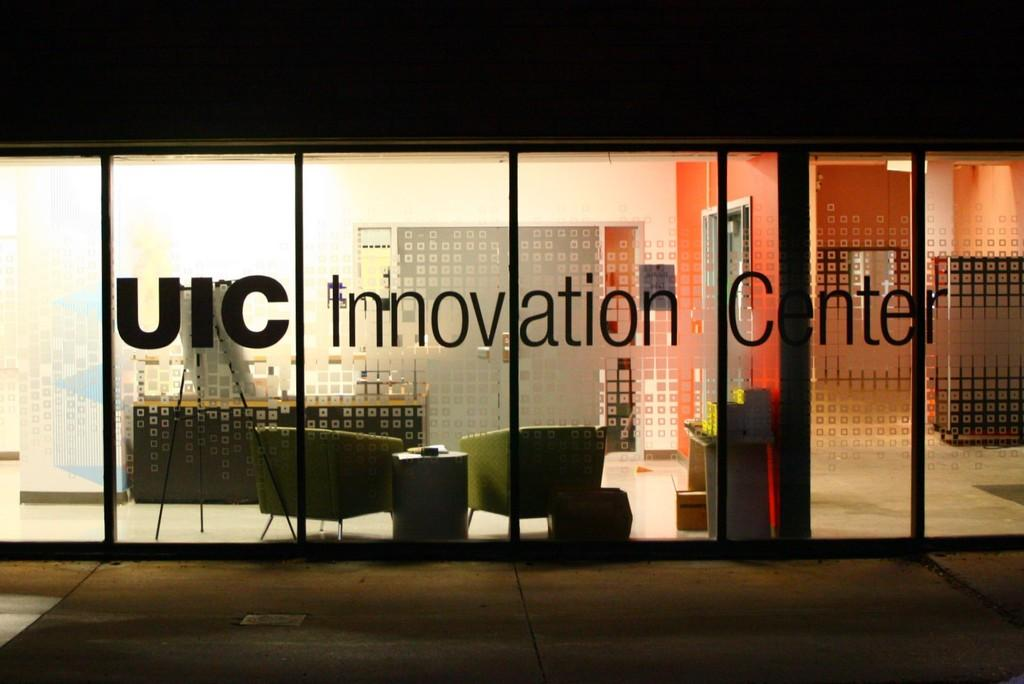What is on the glass windows of the building in the image? There are letters pasted on the glass windows of the building. What is located beside the building? There is a footpath beside the building. What can be seen inside the building through the glass windows? Furniture is visible through the glass windows. What color is the wall visible through the glass windows? There is a white wall visible through the glass windows. What type of jar is being used to establish a connection between the building and the footpath? There is no jar or connection between the building and the footpath mentioned in the image. 